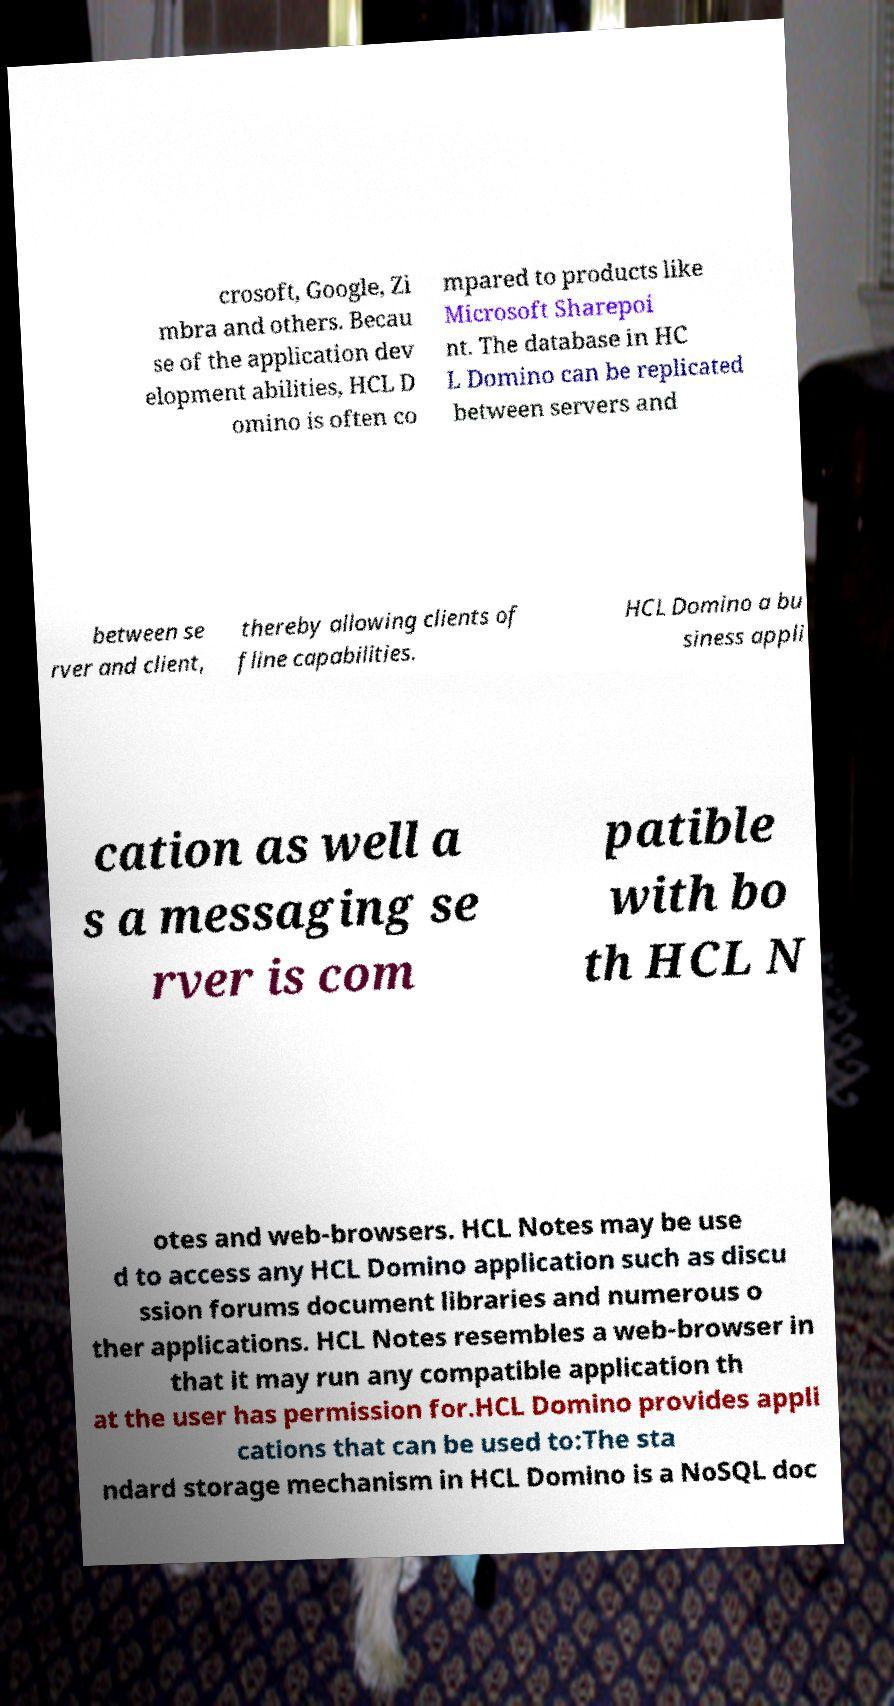What messages or text are displayed in this image? I need them in a readable, typed format. crosoft, Google, Zi mbra and others. Becau se of the application dev elopment abilities, HCL D omino is often co mpared to products like Microsoft Sharepoi nt. The database in HC L Domino can be replicated between servers and between se rver and client, thereby allowing clients of fline capabilities. HCL Domino a bu siness appli cation as well a s a messaging se rver is com patible with bo th HCL N otes and web-browsers. HCL Notes may be use d to access any HCL Domino application such as discu ssion forums document libraries and numerous o ther applications. HCL Notes resembles a web-browser in that it may run any compatible application th at the user has permission for.HCL Domino provides appli cations that can be used to:The sta ndard storage mechanism in HCL Domino is a NoSQL doc 